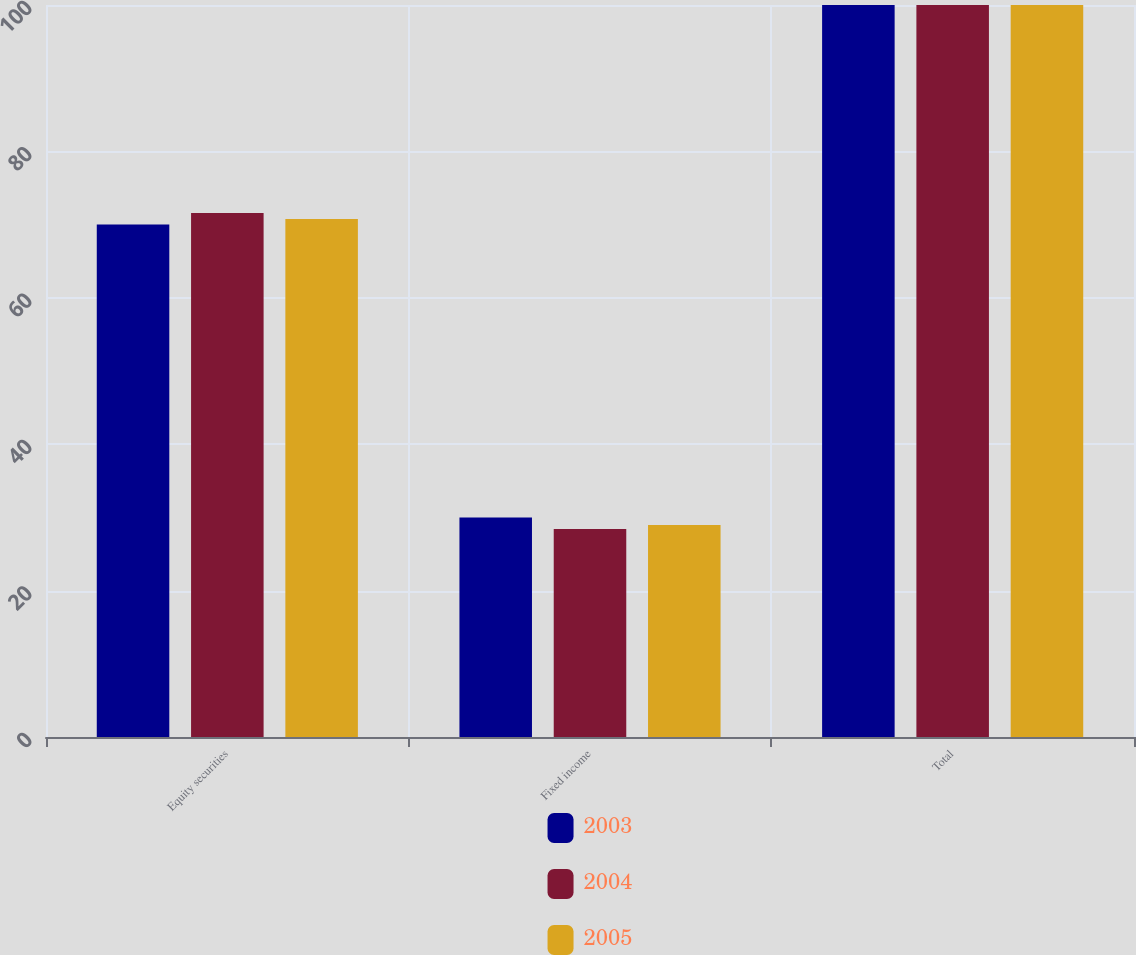Convert chart. <chart><loc_0><loc_0><loc_500><loc_500><stacked_bar_chart><ecel><fcel>Equity securities<fcel>Fixed income<fcel>Total<nl><fcel>2003<fcel>70<fcel>30<fcel>100<nl><fcel>2004<fcel>71.6<fcel>28.4<fcel>100<nl><fcel>2005<fcel>70.75<fcel>28.97<fcel>100<nl></chart> 